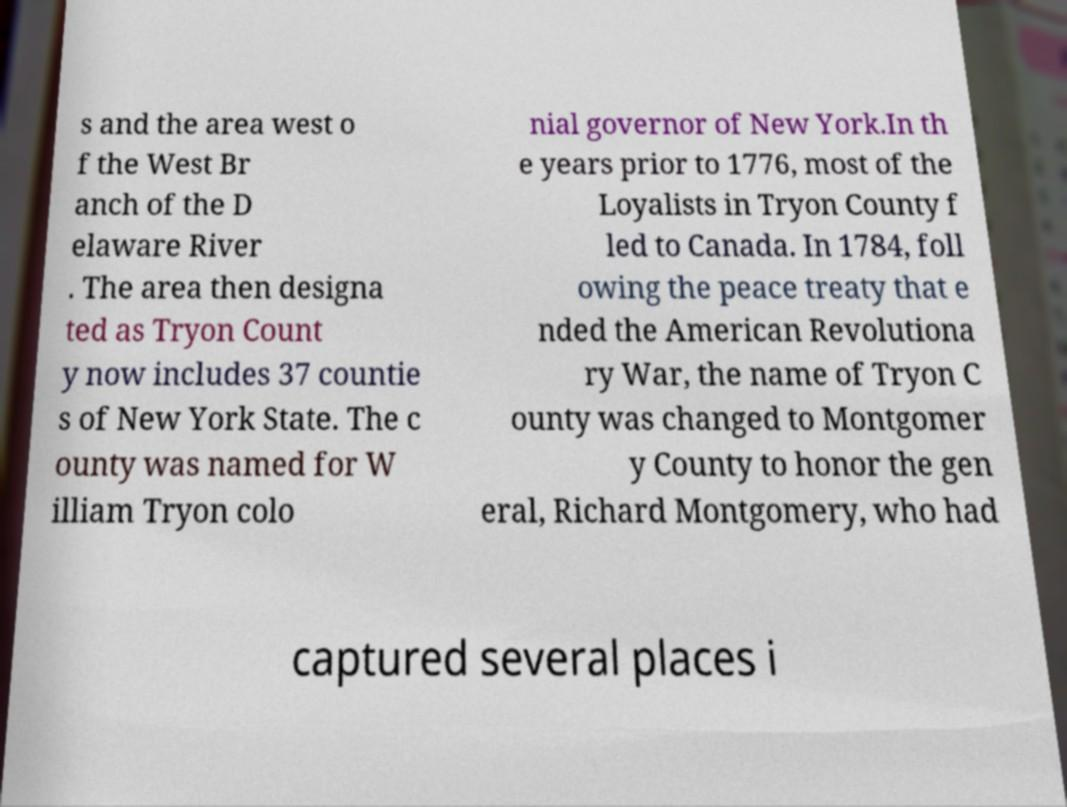Please identify and transcribe the text found in this image. s and the area west o f the West Br anch of the D elaware River . The area then designa ted as Tryon Count y now includes 37 countie s of New York State. The c ounty was named for W illiam Tryon colo nial governor of New York.In th e years prior to 1776, most of the Loyalists in Tryon County f led to Canada. In 1784, foll owing the peace treaty that e nded the American Revolutiona ry War, the name of Tryon C ounty was changed to Montgomer y County to honor the gen eral, Richard Montgomery, who had captured several places i 